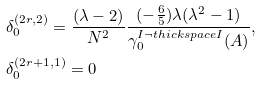Convert formula to latex. <formula><loc_0><loc_0><loc_500><loc_500>& \delta _ { 0 } ^ { ( 2 r , 2 ) } = \frac { ( \lambda - 2 ) } { N ^ { 2 } } \frac { ( - \frac { 6 } { 5 } ) \lambda ( \lambda ^ { 2 } - 1 ) } { \gamma _ { 0 } ^ { I \neg t h i c k s p a c e I } ( A ) } , \\ & \delta _ { 0 } ^ { ( 2 r + 1 , 1 ) } = 0</formula> 